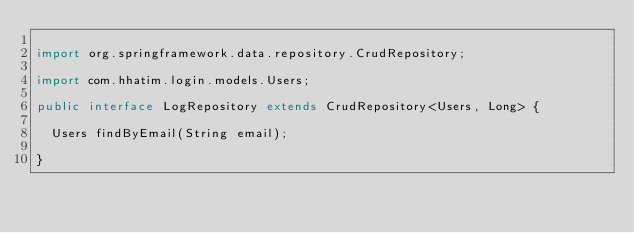<code> <loc_0><loc_0><loc_500><loc_500><_Java_>
import org.springframework.data.repository.CrudRepository;

import com.hhatim.login.models.Users;

public interface LogRepository extends CrudRepository<Users, Long> {
	
	Users findByEmail(String email);

}
</code> 